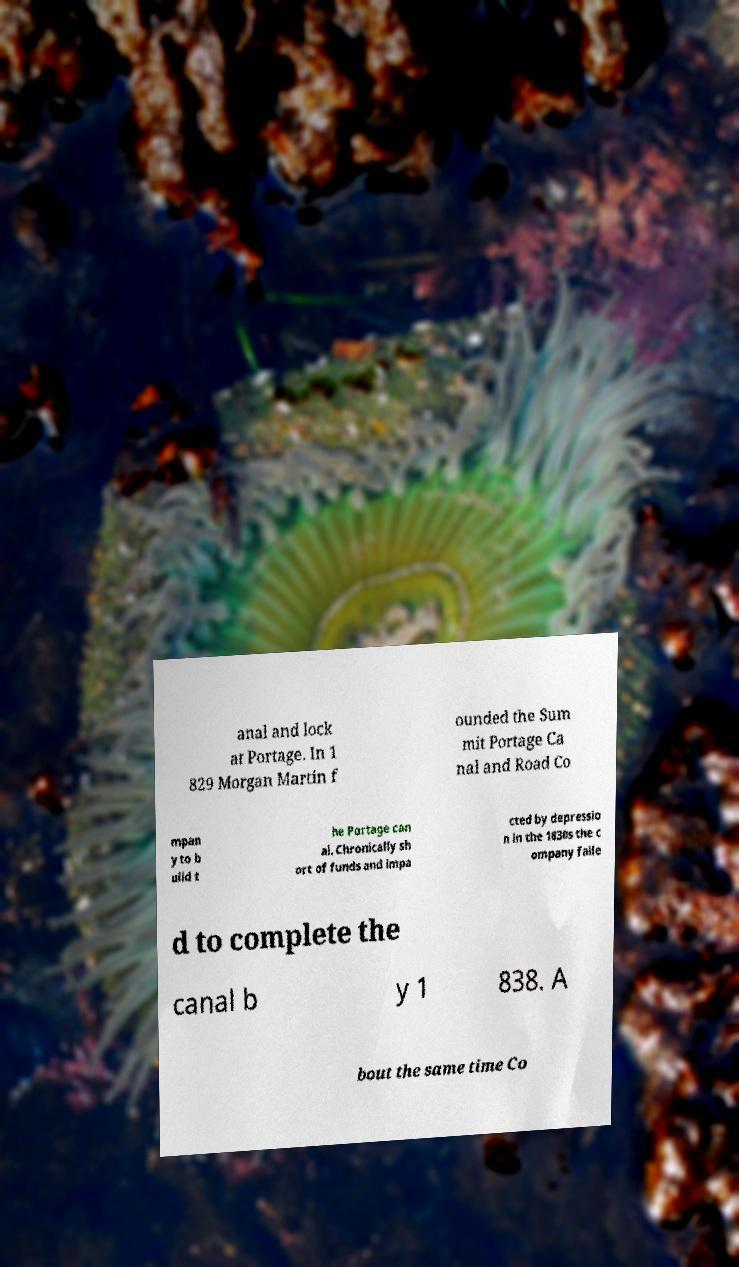There's text embedded in this image that I need extracted. Can you transcribe it verbatim? anal and lock at Portage. In 1 829 Morgan Martin f ounded the Sum mit Portage Ca nal and Road Co mpan y to b uild t he Portage can al. Chronically sh ort of funds and impa cted by depressio n in the 1830s the c ompany faile d to complete the canal b y 1 838. A bout the same time Co 